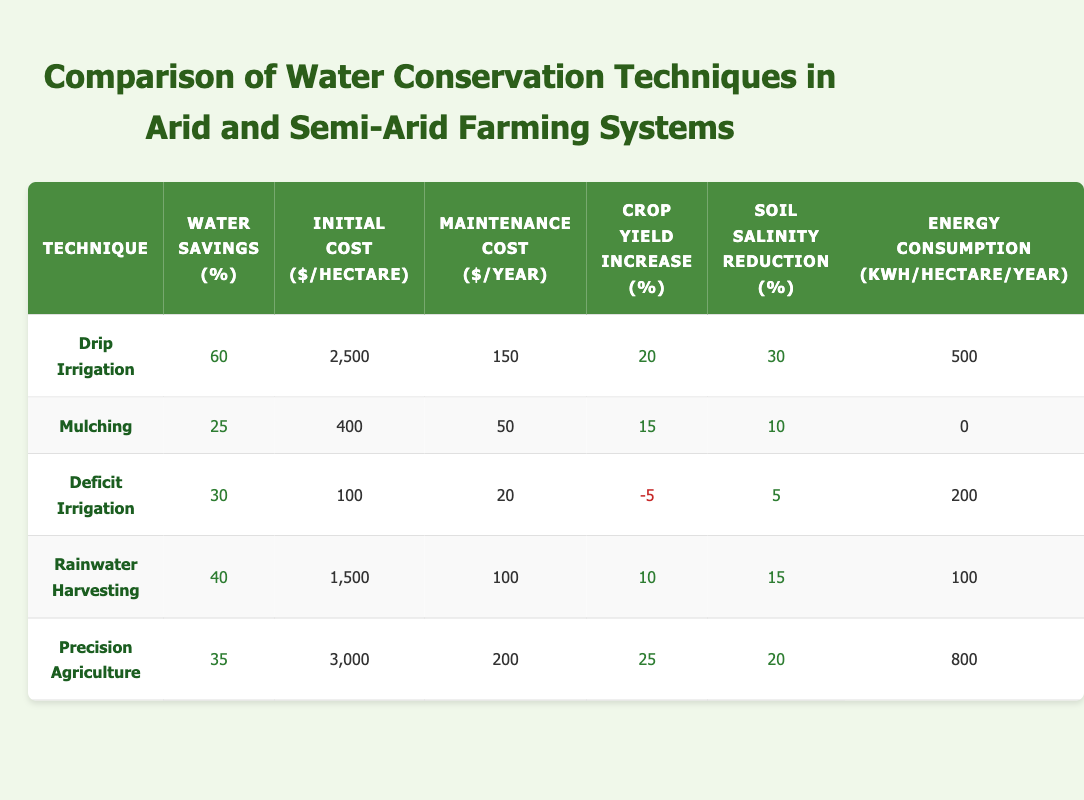What is the water savings percentage from Drip Irrigation? The table lists the water savings percentage for Drip Irrigation, which is shown directly under the "Water Savings (%)" column for this technique.
Answer: 60 What technique has the highest crop yield increase? By examining the "Crop Yield Increase (%)" column, we see that Precision Agriculture has the highest increase at 25%.
Answer: Precision Agriculture What is the total initial cost of implementing both Mulching and Rainwater Harvesting? First, we find the initial costs for both techniques: Mulching is 400 and Rainwater Harvesting is 1500. Adding these together gives 400 + 1500 = 1900.
Answer: 1900 Is the maintenance cost of Deficit Irrigation lower than that of Mulching? The maintenance cost for Deficit Irrigation is 20, while for Mulching it is 50. Since 20 is less than 50, the statement is true.
Answer: Yes Which water conservation technique has the lowest energy consumption? Looking at the "Energy Consumption (kWh/hectare/year)" column, we see Mulching has an energy consumption of 0, which is the lowest compared to all other techniques.
Answer: Mulching What is the average water savings percentage across all the techniques listed? We sum the water savings percentages: 60 + 25 + 30 + 40 + 35 = 190. There are 5 techniques, so we divide 190 by 5. The average is 190/5 = 38.
Answer: 38 Does Precision Agriculture have a negative crop yield increase? Precision Agriculture’s crop yield increase is listed as 25%, which is positive, so the statement is false.
Answer: No Which technique has the greatest reduction in soil salinity? The "Soil Salinity Reduction (%)" column shows Drip Irrigation with a reduction of 30%, which is the highest among all techniques.
Answer: Drip Irrigation What is the difference in initial costs between Drip Irrigation and Deficit Irrigation? The initial cost of Drip Irrigation is 2500, while for Deficit Irrigation it is 100. Subtracting these gives 2500 - 100 = 2400.
Answer: 2400 